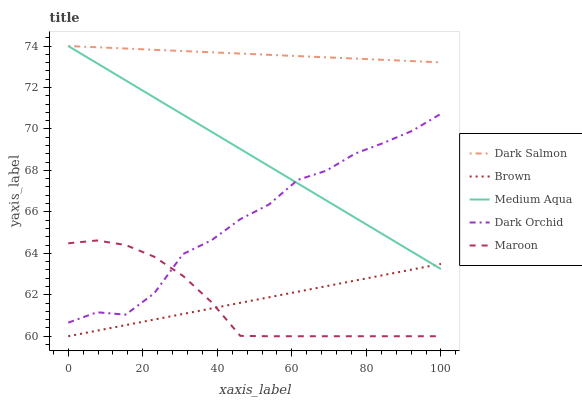Does Maroon have the minimum area under the curve?
Answer yes or no. Yes. Does Dark Salmon have the maximum area under the curve?
Answer yes or no. Yes. Does Brown have the minimum area under the curve?
Answer yes or no. No. Does Brown have the maximum area under the curve?
Answer yes or no. No. Is Medium Aqua the smoothest?
Answer yes or no. Yes. Is Dark Orchid the roughest?
Answer yes or no. Yes. Is Brown the smoothest?
Answer yes or no. No. Is Brown the roughest?
Answer yes or no. No. Does Maroon have the lowest value?
Answer yes or no. Yes. Does Medium Aqua have the lowest value?
Answer yes or no. No. Does Dark Salmon have the highest value?
Answer yes or no. Yes. Does Brown have the highest value?
Answer yes or no. No. Is Brown less than Dark Salmon?
Answer yes or no. Yes. Is Dark Salmon greater than Dark Orchid?
Answer yes or no. Yes. Does Medium Aqua intersect Dark Salmon?
Answer yes or no. Yes. Is Medium Aqua less than Dark Salmon?
Answer yes or no. No. Is Medium Aqua greater than Dark Salmon?
Answer yes or no. No. Does Brown intersect Dark Salmon?
Answer yes or no. No. 